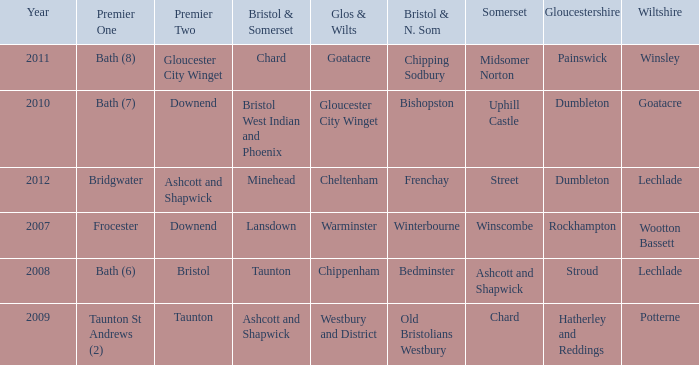Who many times is gloucestershire is painswick? 1.0. 